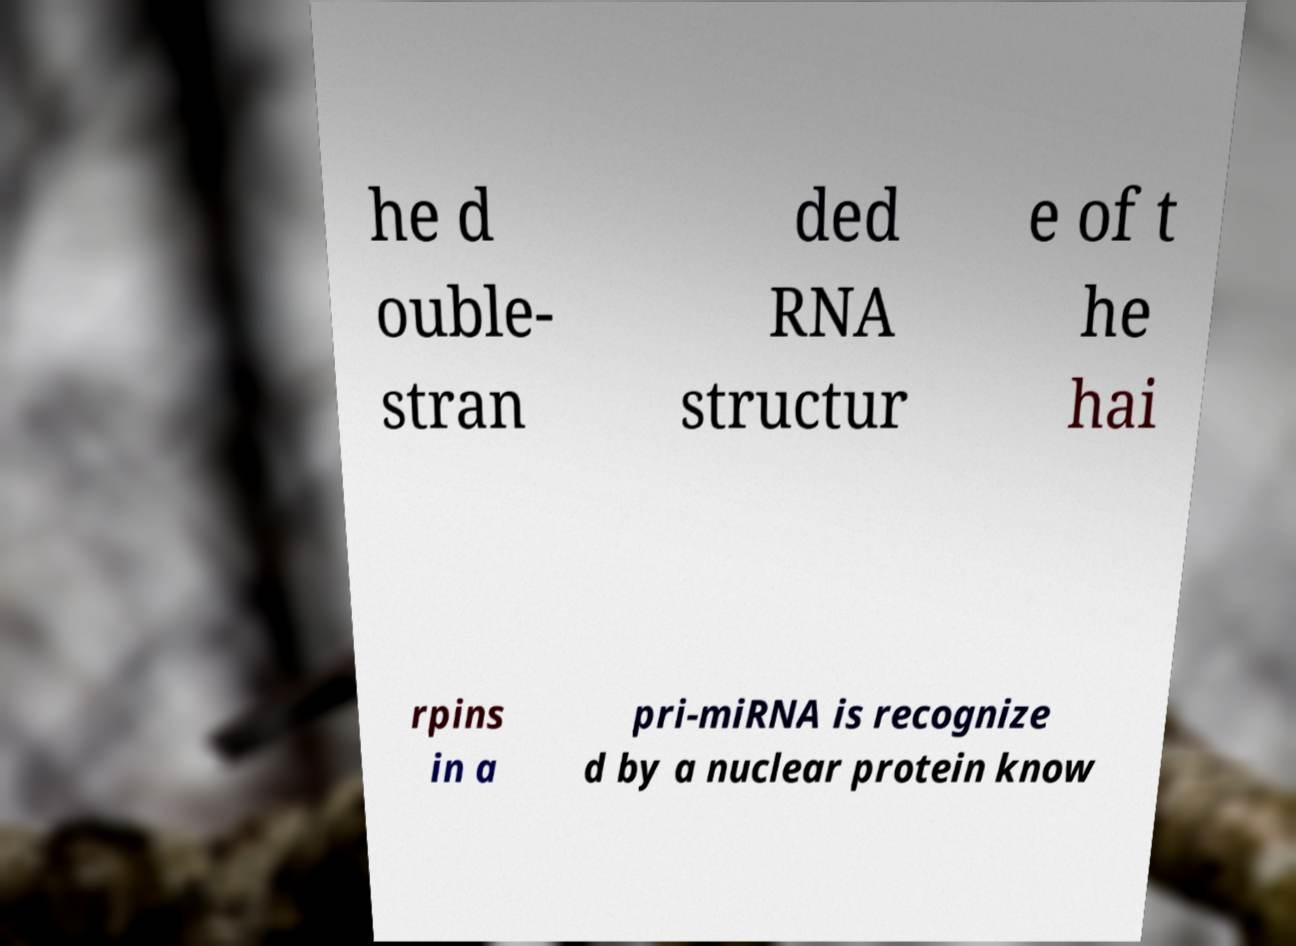Can you read and provide the text displayed in the image?This photo seems to have some interesting text. Can you extract and type it out for me? he d ouble- stran ded RNA structur e of t he hai rpins in a pri-miRNA is recognize d by a nuclear protein know 